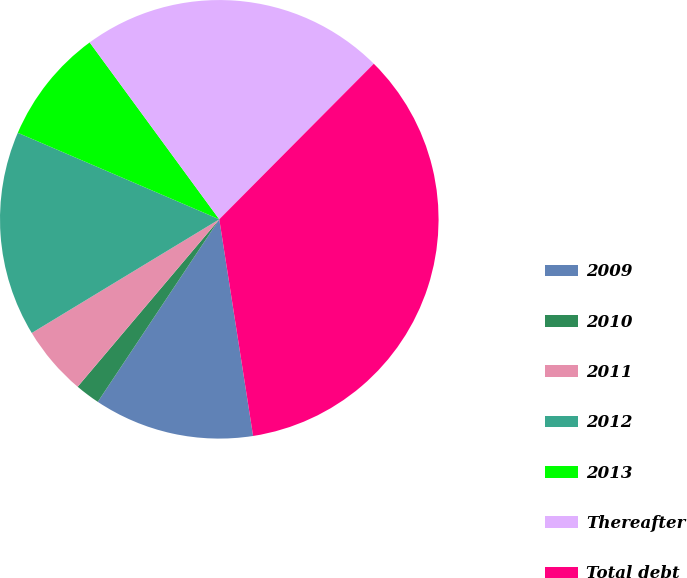Convert chart. <chart><loc_0><loc_0><loc_500><loc_500><pie_chart><fcel>2009<fcel>2010<fcel>2011<fcel>2012<fcel>2013<fcel>Thereafter<fcel>Total debt<nl><fcel>11.81%<fcel>1.83%<fcel>5.15%<fcel>15.13%<fcel>8.48%<fcel>22.51%<fcel>35.09%<nl></chart> 